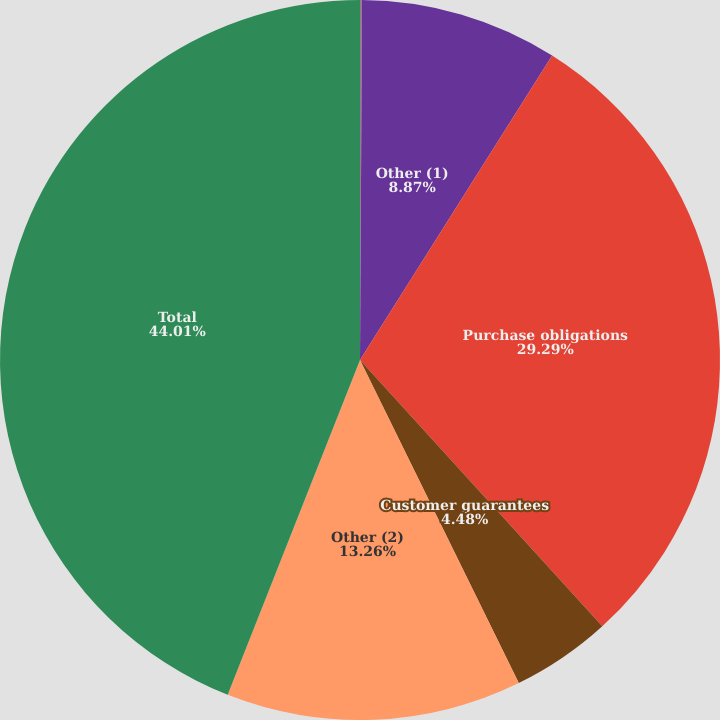Convert chart to OTSL. <chart><loc_0><loc_0><loc_500><loc_500><pie_chart><fcel>Long-term debt<fcel>Other (1)<fcel>Purchase obligations<fcel>Customer guarantees<fcel>Other (2)<fcel>Total<nl><fcel>0.09%<fcel>8.87%<fcel>29.29%<fcel>4.48%<fcel>13.26%<fcel>44.01%<nl></chart> 